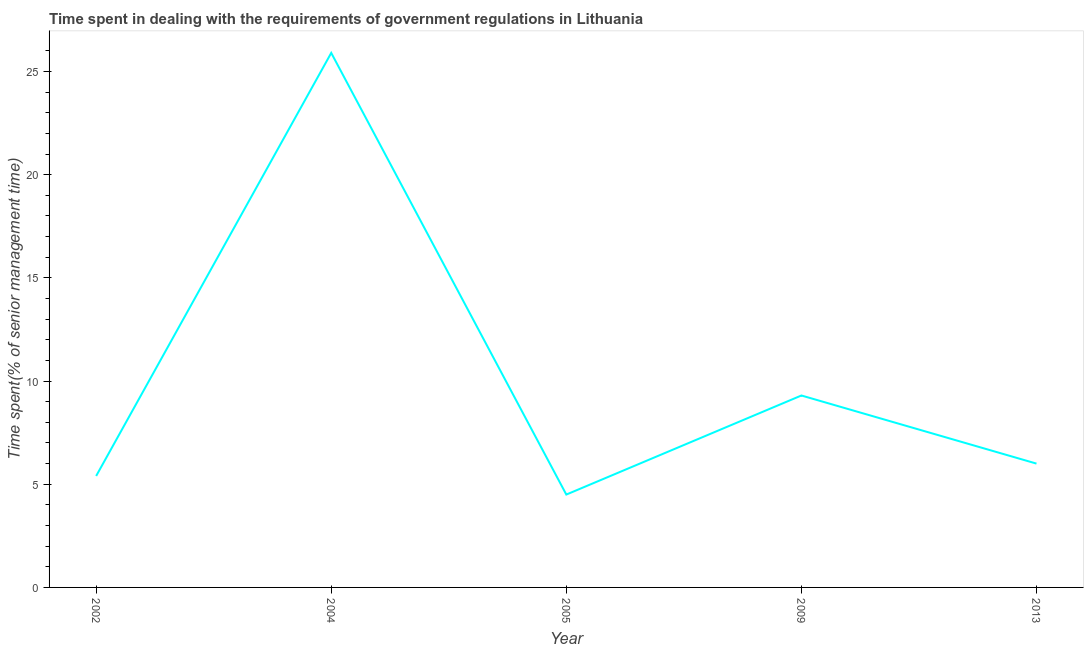What is the time spent in dealing with government regulations in 2013?
Your answer should be very brief. 6. Across all years, what is the maximum time spent in dealing with government regulations?
Offer a very short reply. 25.9. Across all years, what is the minimum time spent in dealing with government regulations?
Your answer should be compact. 4.5. In which year was the time spent in dealing with government regulations maximum?
Provide a succinct answer. 2004. What is the sum of the time spent in dealing with government regulations?
Keep it short and to the point. 51.1. What is the difference between the time spent in dealing with government regulations in 2009 and 2013?
Ensure brevity in your answer.  3.3. What is the average time spent in dealing with government regulations per year?
Keep it short and to the point. 10.22. In how many years, is the time spent in dealing with government regulations greater than 8 %?
Give a very brief answer. 2. What is the ratio of the time spent in dealing with government regulations in 2002 to that in 2004?
Your answer should be compact. 0.21. Is the time spent in dealing with government regulations in 2002 less than that in 2005?
Ensure brevity in your answer.  No. Is the difference between the time spent in dealing with government regulations in 2009 and 2013 greater than the difference between any two years?
Your response must be concise. No. What is the difference between the highest and the second highest time spent in dealing with government regulations?
Make the answer very short. 16.6. What is the difference between the highest and the lowest time spent in dealing with government regulations?
Your answer should be very brief. 21.4. In how many years, is the time spent in dealing with government regulations greater than the average time spent in dealing with government regulations taken over all years?
Provide a short and direct response. 1. Does the time spent in dealing with government regulations monotonically increase over the years?
Provide a short and direct response. No. How many lines are there?
Your answer should be very brief. 1. Are the values on the major ticks of Y-axis written in scientific E-notation?
Ensure brevity in your answer.  No. What is the title of the graph?
Provide a succinct answer. Time spent in dealing with the requirements of government regulations in Lithuania. What is the label or title of the Y-axis?
Your answer should be compact. Time spent(% of senior management time). What is the Time spent(% of senior management time) of 2002?
Provide a succinct answer. 5.4. What is the Time spent(% of senior management time) of 2004?
Your response must be concise. 25.9. What is the Time spent(% of senior management time) in 2009?
Your response must be concise. 9.3. What is the Time spent(% of senior management time) of 2013?
Offer a very short reply. 6. What is the difference between the Time spent(% of senior management time) in 2002 and 2004?
Your answer should be very brief. -20.5. What is the difference between the Time spent(% of senior management time) in 2002 and 2013?
Your answer should be compact. -0.6. What is the difference between the Time spent(% of senior management time) in 2004 and 2005?
Your response must be concise. 21.4. What is the difference between the Time spent(% of senior management time) in 2004 and 2013?
Give a very brief answer. 19.9. What is the difference between the Time spent(% of senior management time) in 2005 and 2009?
Your answer should be very brief. -4.8. What is the difference between the Time spent(% of senior management time) in 2009 and 2013?
Provide a short and direct response. 3.3. What is the ratio of the Time spent(% of senior management time) in 2002 to that in 2004?
Your answer should be very brief. 0.21. What is the ratio of the Time spent(% of senior management time) in 2002 to that in 2005?
Provide a succinct answer. 1.2. What is the ratio of the Time spent(% of senior management time) in 2002 to that in 2009?
Offer a very short reply. 0.58. What is the ratio of the Time spent(% of senior management time) in 2002 to that in 2013?
Offer a very short reply. 0.9. What is the ratio of the Time spent(% of senior management time) in 2004 to that in 2005?
Provide a succinct answer. 5.76. What is the ratio of the Time spent(% of senior management time) in 2004 to that in 2009?
Ensure brevity in your answer.  2.79. What is the ratio of the Time spent(% of senior management time) in 2004 to that in 2013?
Your response must be concise. 4.32. What is the ratio of the Time spent(% of senior management time) in 2005 to that in 2009?
Keep it short and to the point. 0.48. What is the ratio of the Time spent(% of senior management time) in 2005 to that in 2013?
Your response must be concise. 0.75. What is the ratio of the Time spent(% of senior management time) in 2009 to that in 2013?
Provide a short and direct response. 1.55. 